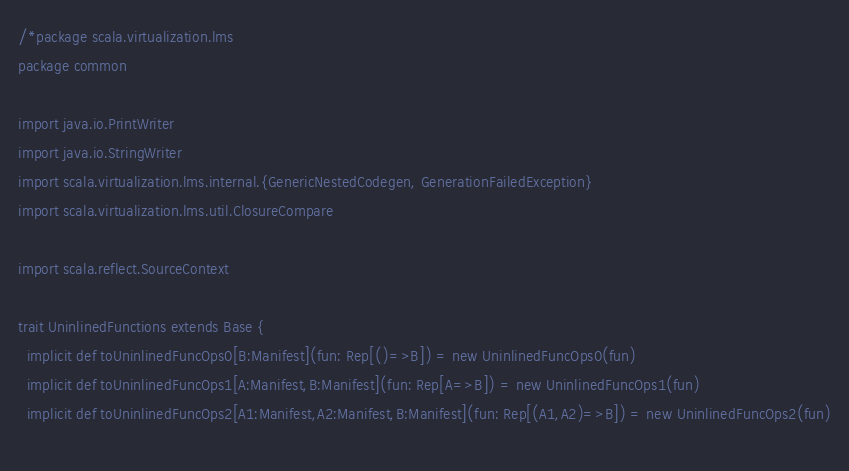Convert code to text. <code><loc_0><loc_0><loc_500><loc_500><_Scala_>/*package scala.virtualization.lms
package common

import java.io.PrintWriter
import java.io.StringWriter
import scala.virtualization.lms.internal.{GenericNestedCodegen, GenerationFailedException}
import scala.virtualization.lms.util.ClosureCompare

import scala.reflect.SourceContext

trait UninlinedFunctions extends Base { 
  implicit def toUninlinedFuncOps0[B:Manifest](fun: Rep[()=>B]) = new UninlinedFuncOps0(fun)
  implicit def toUninlinedFuncOps1[A:Manifest,B:Manifest](fun: Rep[A=>B]) = new UninlinedFuncOps1(fun)
  implicit def toUninlinedFuncOps2[A1:Manifest,A2:Manifest,B:Manifest](fun: Rep[(A1,A2)=>B]) = new UninlinedFuncOps2(fun)
  </code> 